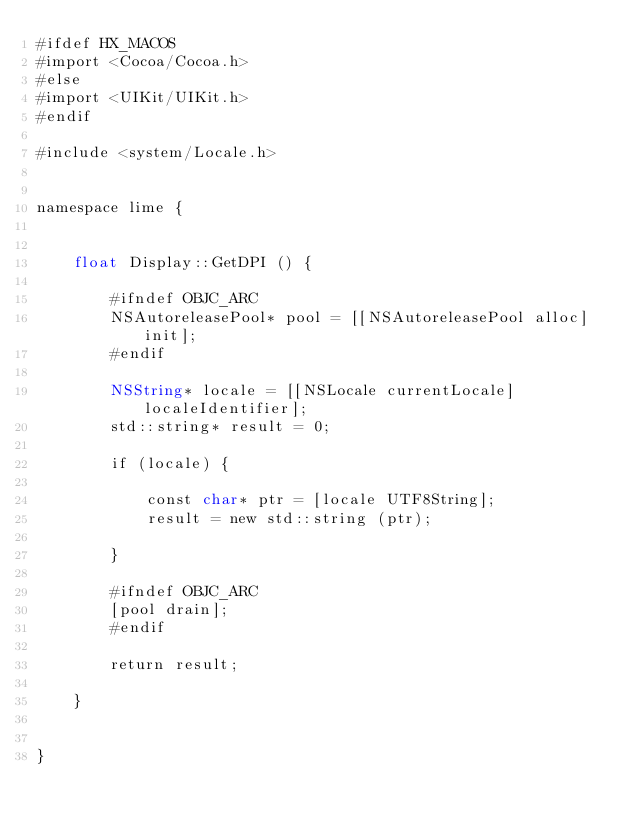Convert code to text. <code><loc_0><loc_0><loc_500><loc_500><_ObjectiveC_>#ifdef HX_MACOS
#import <Cocoa/Cocoa.h>
#else
#import <UIKit/UIKit.h>
#endif

#include <system/Locale.h>


namespace lime {
	
	
	float Display::GetDPI () {
		
		#ifndef OBJC_ARC
		NSAutoreleasePool* pool = [[NSAutoreleasePool alloc] init];
		#endif
		
		NSString* locale = [[NSLocale currentLocale] localeIdentifier];
		std::string* result = 0;
		
		if (locale) {
			
			const char* ptr = [locale UTF8String];
			result = new std::string (ptr);
			
		}
		
		#ifndef OBJC_ARC
		[pool drain];
		#endif
		
		return result;
		
	}
	
	
}</code> 